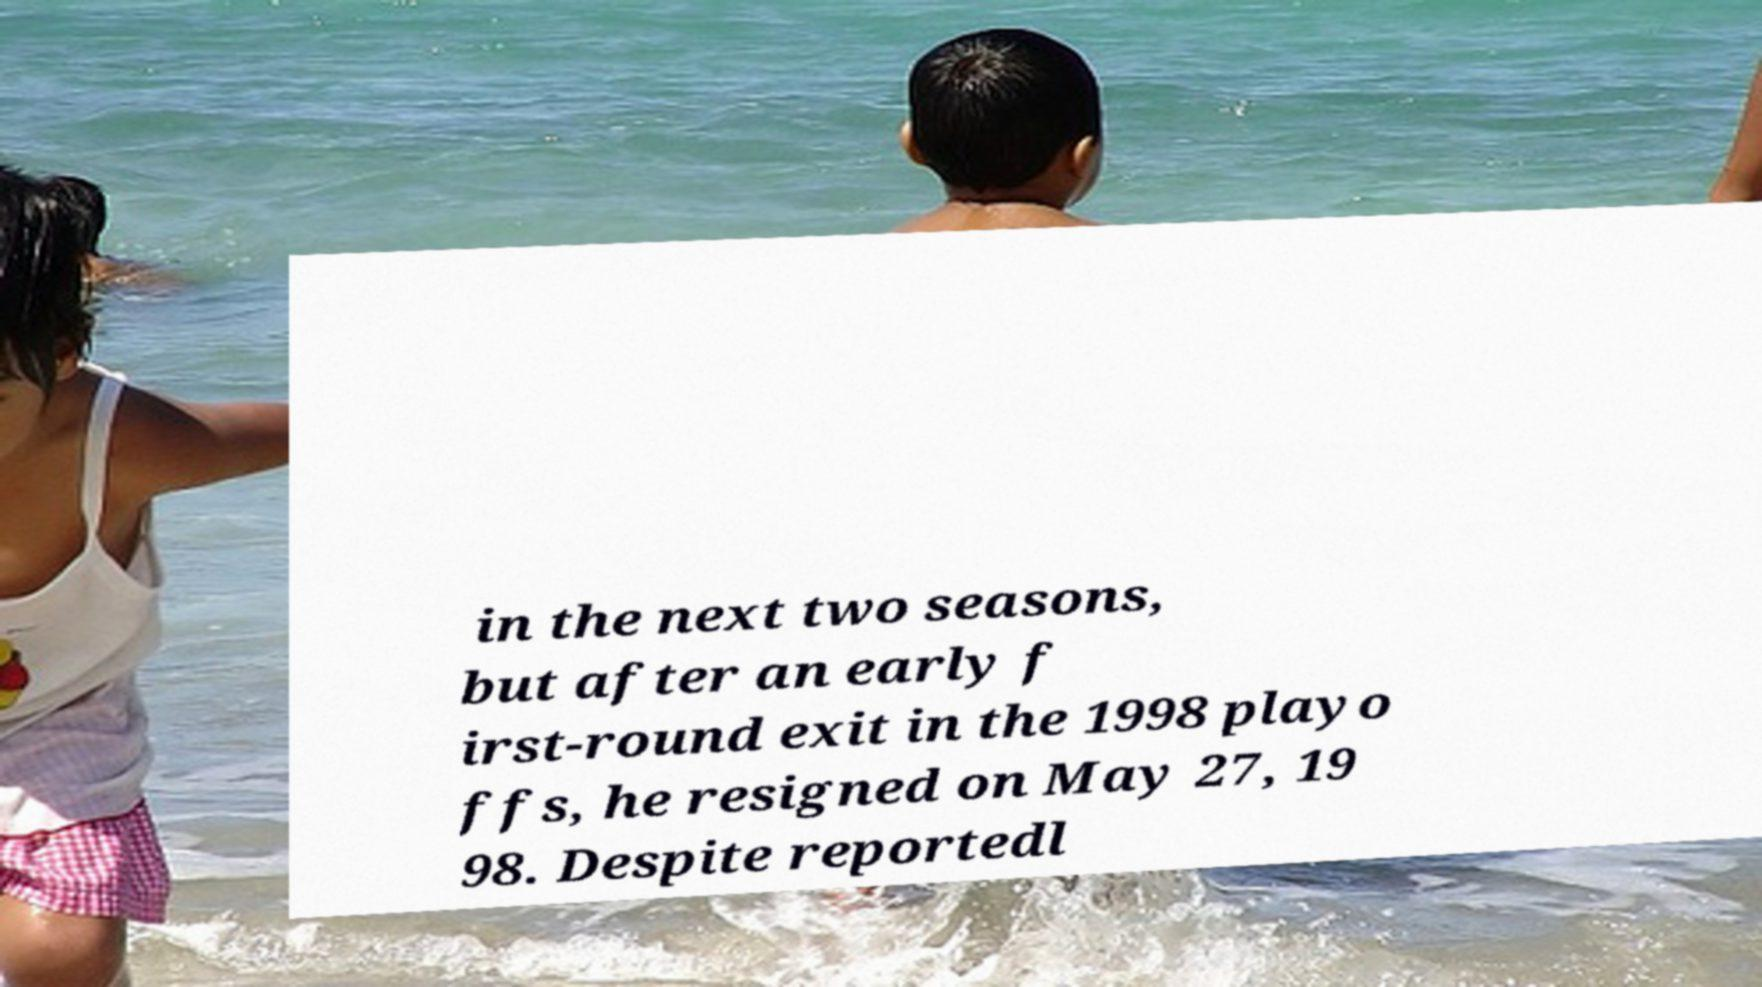Can you read and provide the text displayed in the image?This photo seems to have some interesting text. Can you extract and type it out for me? in the next two seasons, but after an early f irst-round exit in the 1998 playo ffs, he resigned on May 27, 19 98. Despite reportedl 